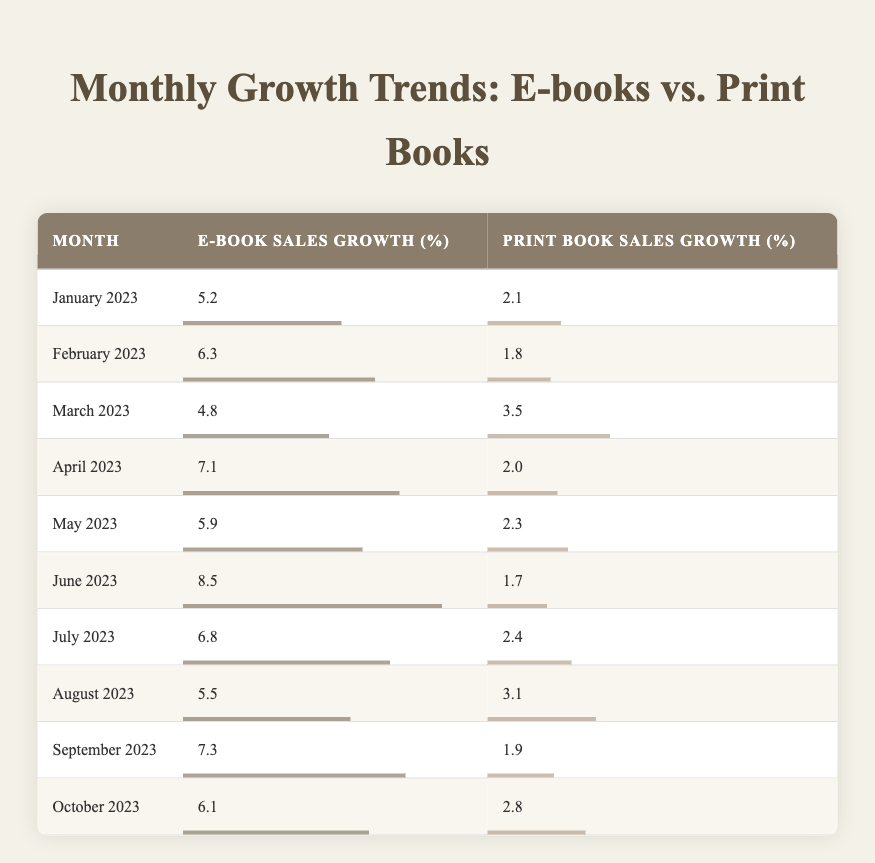What was the e-book sales growth percentage for April 2023? The table lists the e-book sales growth percentage for each month. Looking specifically at April 2023, the table shows that the e-book sales growth percentage is 7.1.
Answer: 7.1 Which month saw the highest print book sales growth, and what was that percentage? By scanning through the print book sales growth percentages in the table, we can identify that June 2023 has the highest value at 1.7 for print book sales growth.
Answer: 1.7 What is the average e-book sales growth percentage over the ten months listed? To find the average, the e-book growth percentages for all ten months must be added together (5.2 + 6.3 + 4.8 + 7.1 + 5.9 + 8.5 + 6.8 + 5.5 + 7.3 + 6.1) = 56.5. Then, we divide this sum by the number of months (10): 56.5 / 10 = 5.65.
Answer: 5.65 In which month did e-book sales growth surpass print book sales growth by the highest margin? Calculating the differences between e-book and print book sales growth each month shows that the month with the highest difference is June 2023, where e-book growth is 8.5 and print growth is 1.7, resulting in a margin of 6.8.
Answer: June 2023 True or False: Print book sales growth was higher than e-book sales growth in any month from January to October 2023. Looking at the table month by month, it's clear that in all months listed, e-book sales growth was consistently higher than print book sales growth, indicating that the statement is false.
Answer: False How many months had e-book sales growth percentages greater than 6%? By reviewing the e-book sales growth percentages, we find that January (5.2), February (6.3), March (4.8), April (7.1), May (5.9), June (8.5), July (6.8), August (5.5), September (7.3), and October (6.1) result in five months (February, April, June, July, September) with growth above 6%.
Answer: 5 What was the total growth percentage for print book sales from January to October 2023? Adding the print book sales growth percentages for all the months gives us (2.1 + 1.8 + 3.5 + 2.0 + 2.3 + 1.7 + 2.4 + 3.1 + 1.9 + 2.8) = 23.6. This represents the total growth percentage over the period.
Answer: 23.6 Which month had e-book sales growth just below 6%, and what was the exact percentage? Reviewing the e-book sales growth percentages, we can see that the month of May has an e-book growth of 5.9, which is just below 6%.
Answer: May 2023 